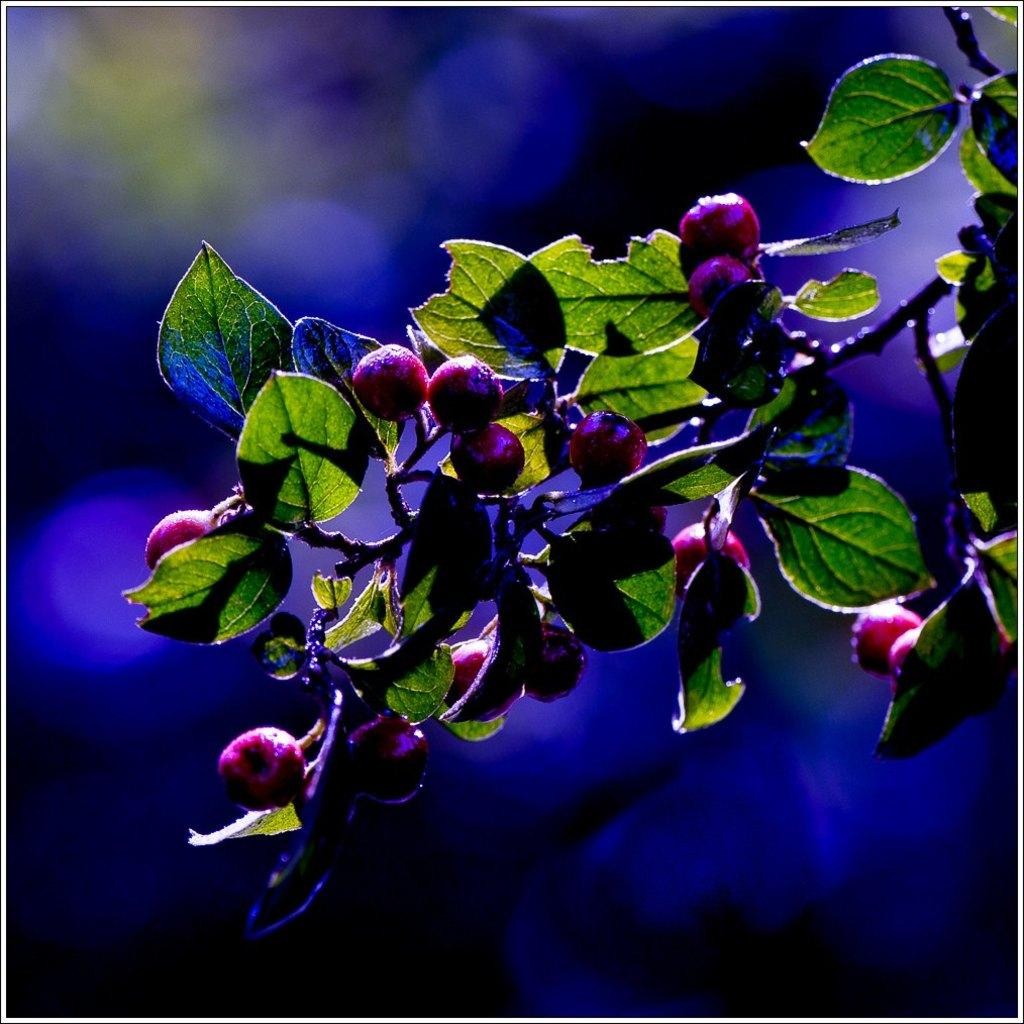What type of plant or tree is visible in the image? There is a plant or tree with fruits in the image. What color are the fruits on the plant or tree? The fruits are red in color. What can be seen in the background of the image? The background of the image is blue and blurred. What brand of toothpaste is being advertised in the image? There is no toothpaste or advertisement present in the image. What attempt is being made by the plant or tree in the image? The plant or tree is not making any attempt; it is simply growing and bearing fruits. 